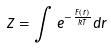Convert formula to latex. <formula><loc_0><loc_0><loc_500><loc_500>Z = \int e ^ { - \frac { F ( r ) } { k T } } d r</formula> 